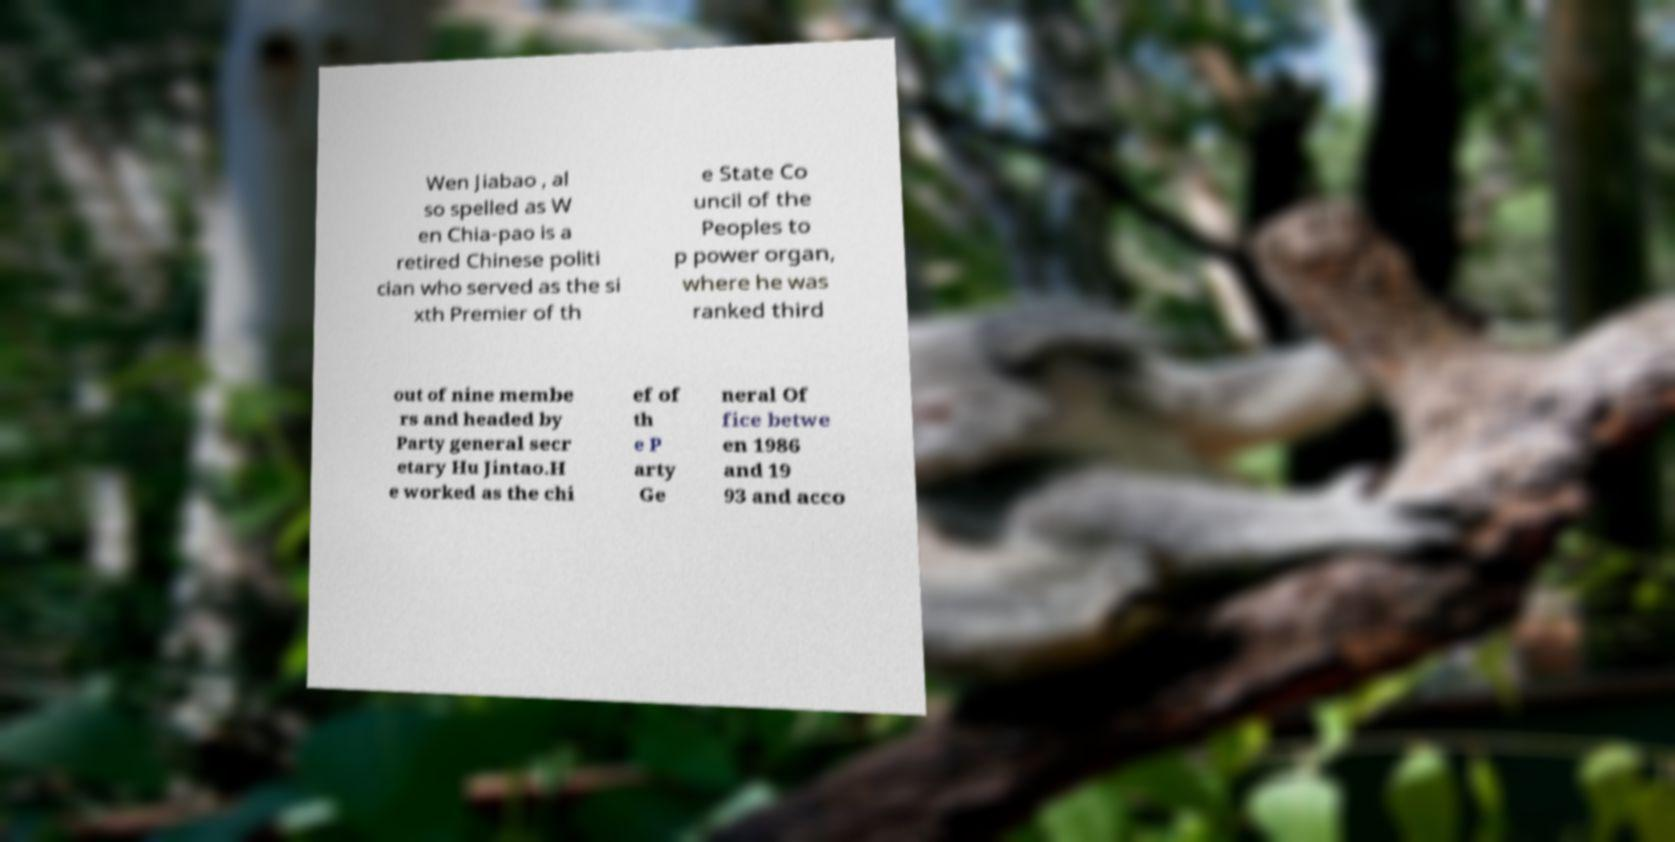Can you read and provide the text displayed in the image?This photo seems to have some interesting text. Can you extract and type it out for me? Wen Jiabao , al so spelled as W en Chia-pao is a retired Chinese politi cian who served as the si xth Premier of th e State Co uncil of the Peoples to p power organ, where he was ranked third out of nine membe rs and headed by Party general secr etary Hu Jintao.H e worked as the chi ef of th e P arty Ge neral Of fice betwe en 1986 and 19 93 and acco 